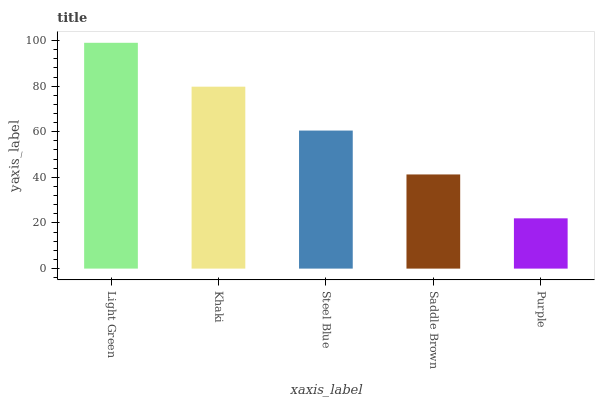Is Purple the minimum?
Answer yes or no. Yes. Is Light Green the maximum?
Answer yes or no. Yes. Is Khaki the minimum?
Answer yes or no. No. Is Khaki the maximum?
Answer yes or no. No. Is Light Green greater than Khaki?
Answer yes or no. Yes. Is Khaki less than Light Green?
Answer yes or no. Yes. Is Khaki greater than Light Green?
Answer yes or no. No. Is Light Green less than Khaki?
Answer yes or no. No. Is Steel Blue the high median?
Answer yes or no. Yes. Is Steel Blue the low median?
Answer yes or no. Yes. Is Purple the high median?
Answer yes or no. No. Is Saddle Brown the low median?
Answer yes or no. No. 